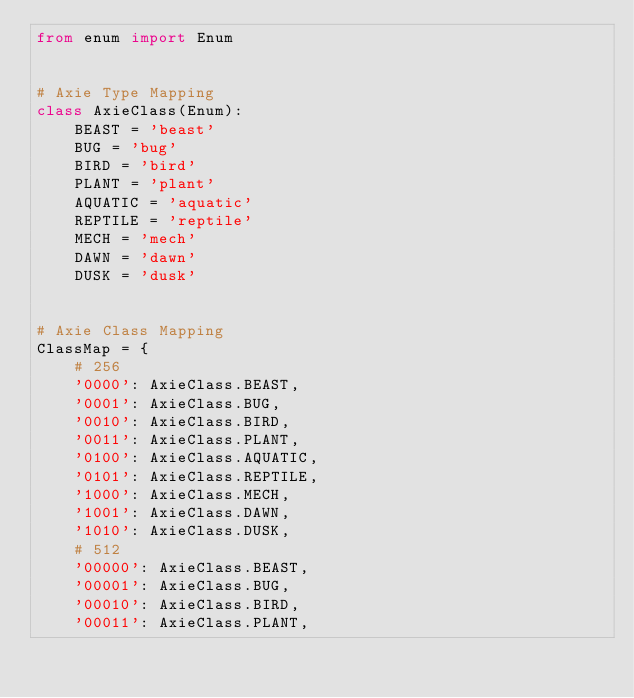Convert code to text. <code><loc_0><loc_0><loc_500><loc_500><_Python_>from enum import Enum


# Axie Type Mapping
class AxieClass(Enum):
    BEAST = 'beast'
    BUG = 'bug'
    BIRD = 'bird'
    PLANT = 'plant'
    AQUATIC = 'aquatic'
    REPTILE = 'reptile'
    MECH = 'mech'
    DAWN = 'dawn'
    DUSK = 'dusk'


# Axie Class Mapping
ClassMap = {
    # 256
    '0000': AxieClass.BEAST,
    '0001': AxieClass.BUG,
    '0010': AxieClass.BIRD,
    '0011': AxieClass.PLANT,
    '0100': AxieClass.AQUATIC,
    '0101': AxieClass.REPTILE,
    '1000': AxieClass.MECH,
    '1001': AxieClass.DAWN,
    '1010': AxieClass.DUSK,
    # 512
    '00000': AxieClass.BEAST,
    '00001': AxieClass.BUG,
    '00010': AxieClass.BIRD,
    '00011': AxieClass.PLANT,</code> 